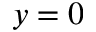Convert formula to latex. <formula><loc_0><loc_0><loc_500><loc_500>y = 0</formula> 